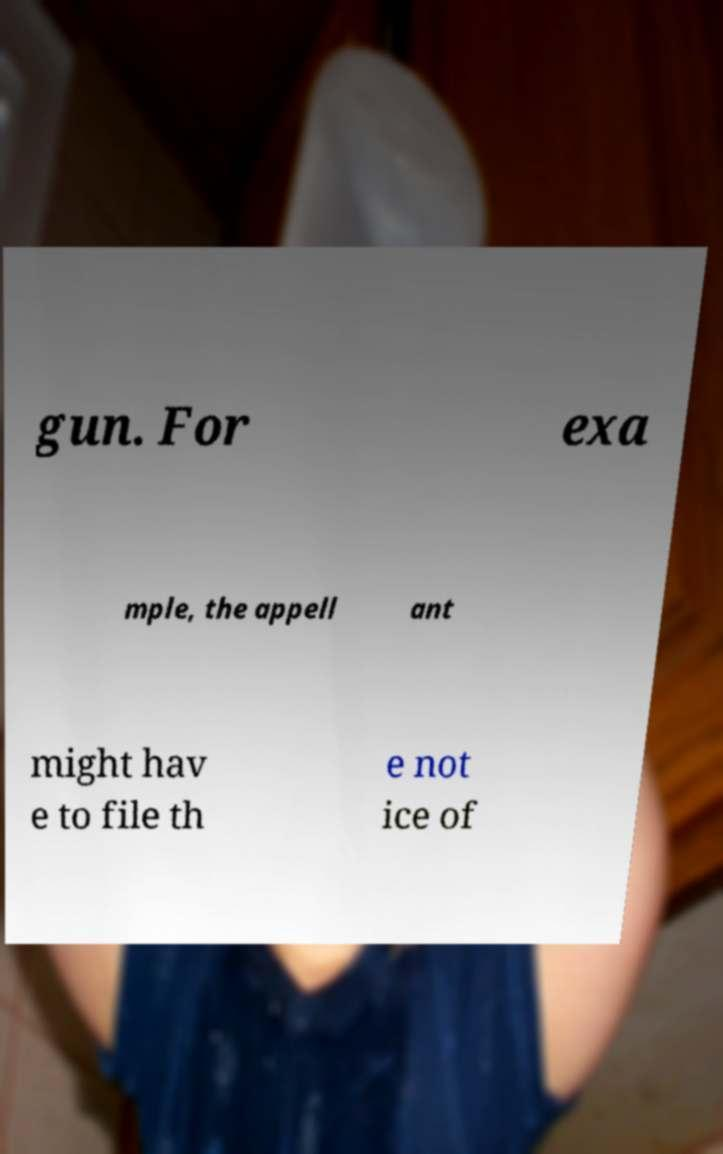Can you read and provide the text displayed in the image?This photo seems to have some interesting text. Can you extract and type it out for me? gun. For exa mple, the appell ant might hav e to file th e not ice of 